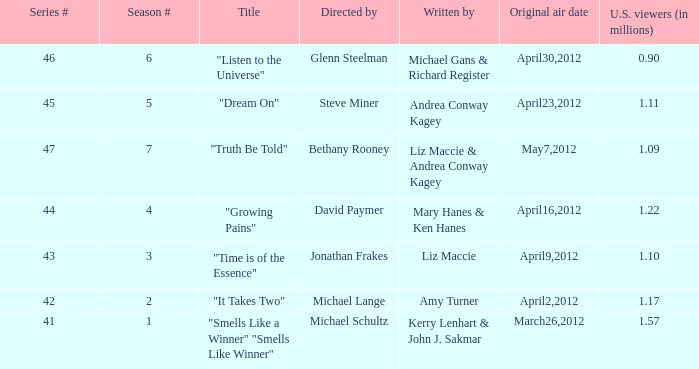What are the titles of the episodes which had 1.10 million U.S. viewers? "Time is of the Essence". 